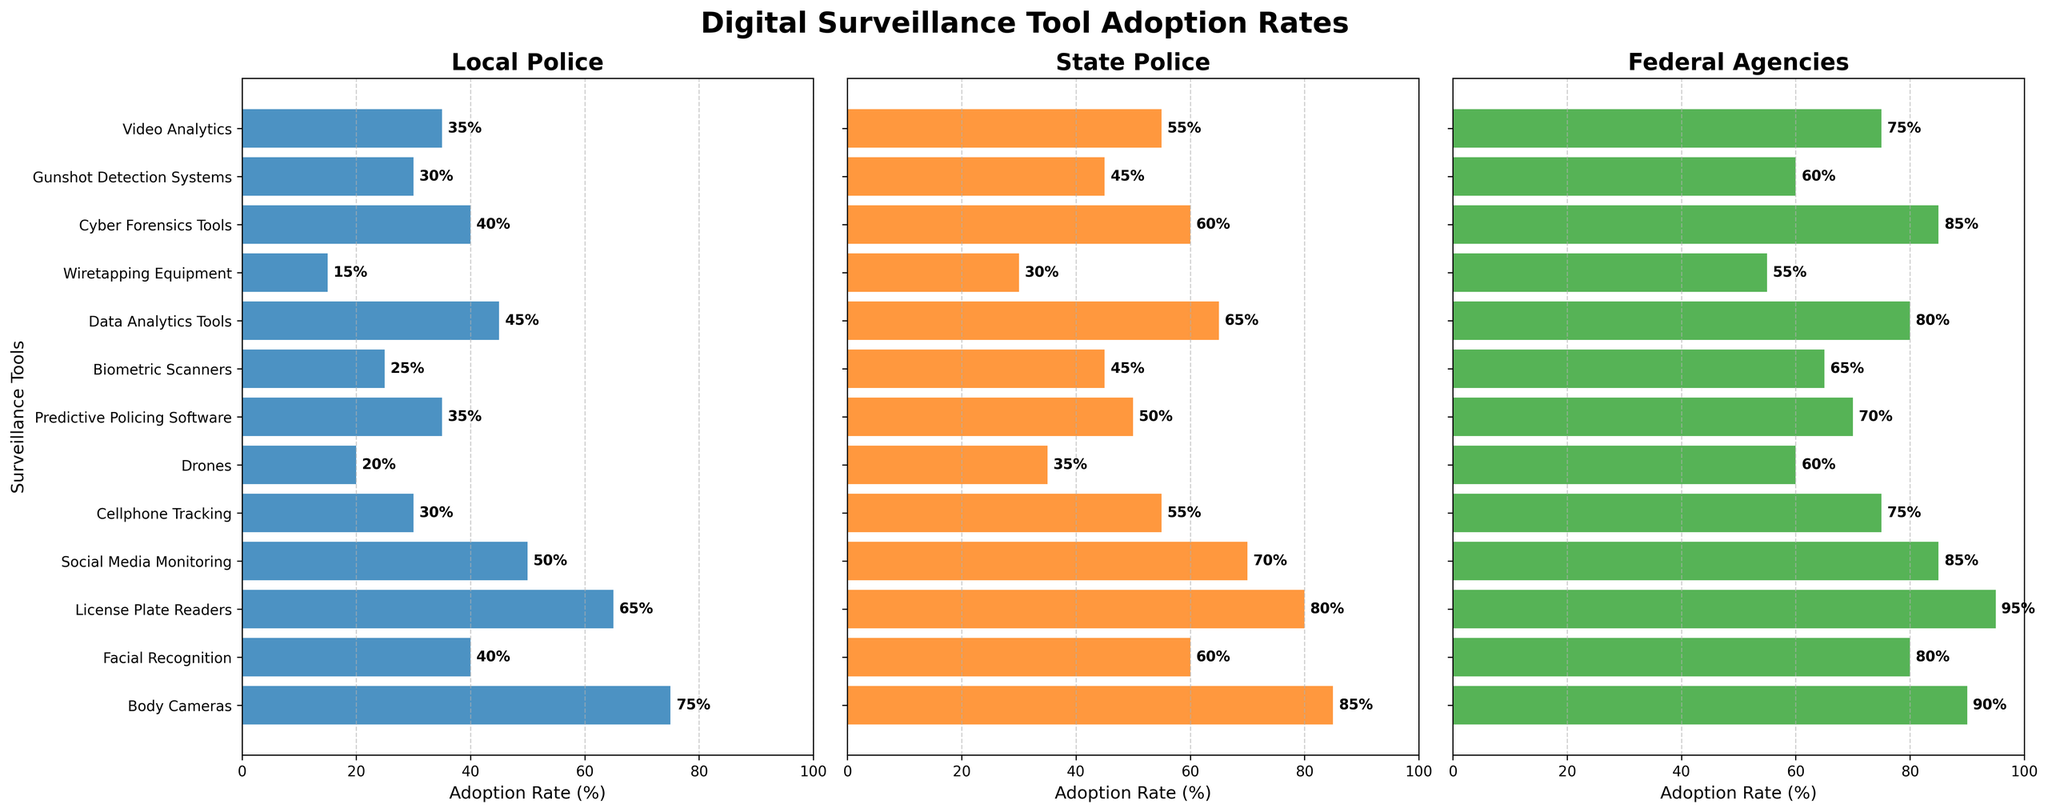Which agency uses body cameras the most? By looking at the bars for body cameras, the bar for Federal Agencies is the longest, indicating that they have the highest adoption rate.
Answer: Federal Agencies What is the difference in adoption rates of facial recognition between Local Police and State Police? The figure shows adoption rates of 40% for Local Police and 60% for State Police. The difference is 60% - 40% = 20%.
Answer: 20% Which surveillance tool has the least adoption rate among Local Police? Looking at the height of the bars for Local Police, Wiretapping Equipment has the shortest bar, indicating it has the least adoption rate.
Answer: Wiretapping Equipment What is the average adoption rate of predictive policing software across all agencies? The adoption rates are 35% for Local Police, 50% for State Police, and 70% for Federal Agencies. The average is (35 + 50 + 70) / 3 = 51.67%.
Answer: 51.67% How many agencies have greater than 60% adoption rate for cell phone tracking? By examining the graphs, State Police (55%) and Federal Agencies (75%) are the ones to consider. Only Federal Agencies have an adoption rate greater than 60%.
Answer: 1 Which agency has the highest adoption of cyber forensic tools? By visually comparing the length of the bars for Cyber Forensics Tools, the Federal Agencies bar is the longest.
Answer: Federal Agencies What is the ratio of the adoption rate of drones between Local Police and Federal Agencies? Local Police have a 20% adoption rate, and Federal Agencies have a 60% adoption rate. The ratio is 20:60, which simplifies to 1:3.
Answer: 1:3 Is social media monitoring more commonly adopted by State Police compared to Local Police? The bar for social media monitoring in the State Police subplot is longer than in the Local Police subplot, indicating a higher adoption rate of 70% compared to 50%.
Answer: Yes What is the combined adoption rate of biometric scanners for Local Police and State Police? Local Police have a 25% adoption rate, and State Police have a 45% adoption rate. The total is 25% + 45% = 70%.
Answer: 70% Which tool has the closest adoption rate between Local Police and State Police? By visually inspecting the bars, the Video Analytics tool has rates of 35% (Local Police) and 55% (State Police), with a difference of 20%, which is the smallest among the compared tools.
Answer: Video Analytics 